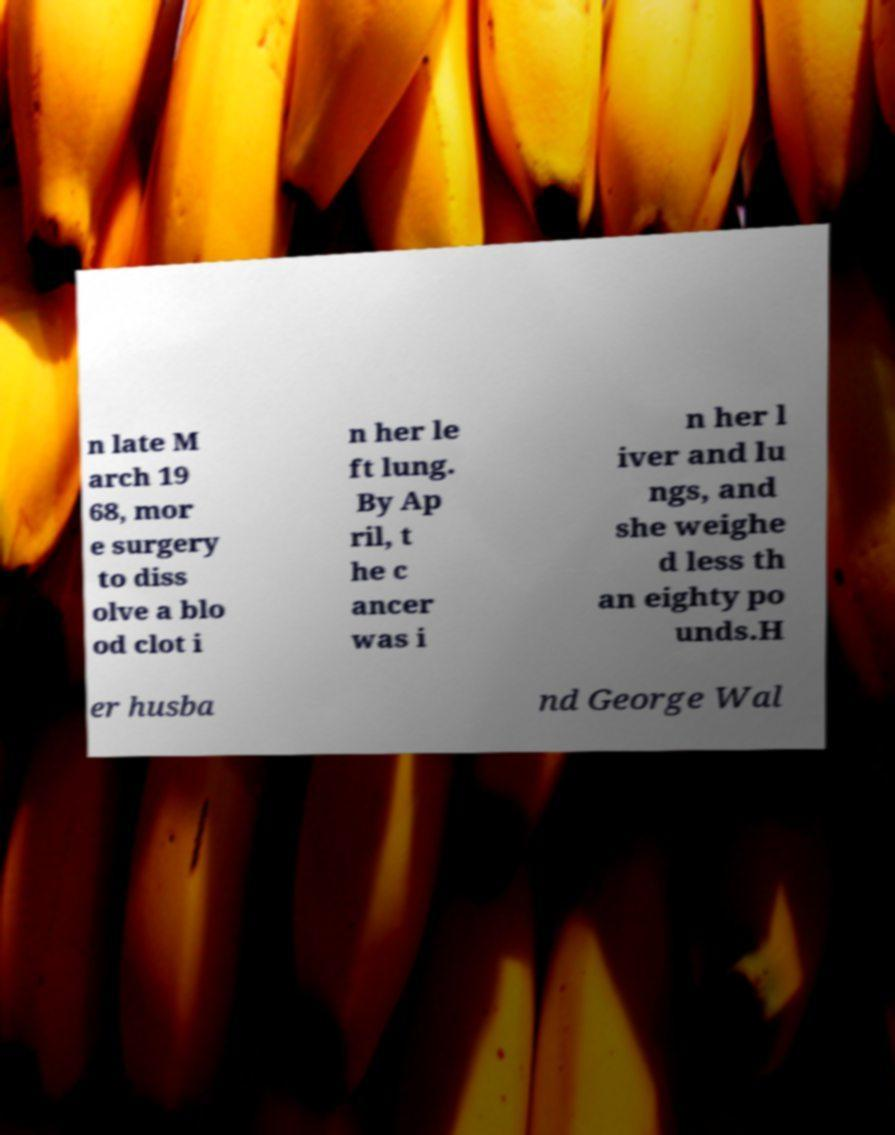Could you extract and type out the text from this image? n late M arch 19 68, mor e surgery to diss olve a blo od clot i n her le ft lung. By Ap ril, t he c ancer was i n her l iver and lu ngs, and she weighe d less th an eighty po unds.H er husba nd George Wal 